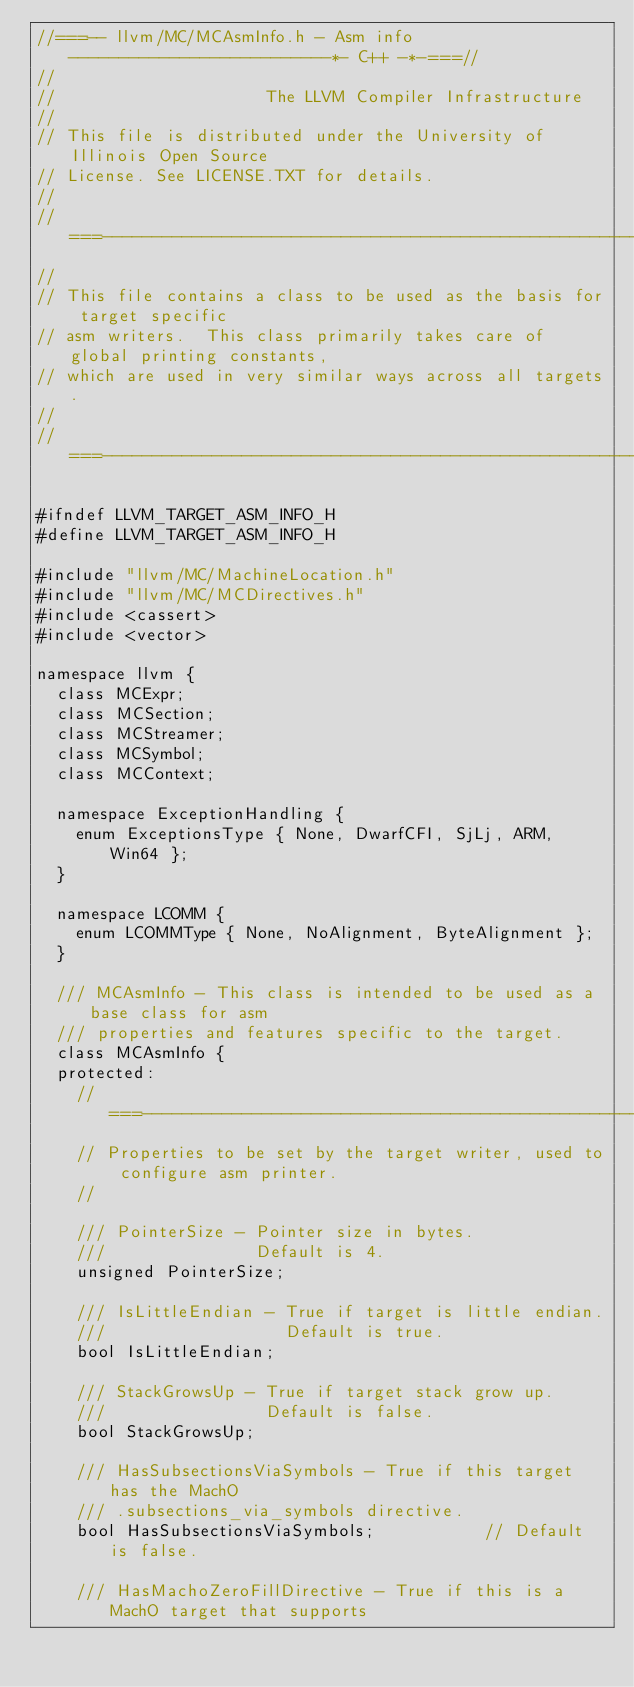Convert code to text. <code><loc_0><loc_0><loc_500><loc_500><_C_>//===-- llvm/MC/MCAsmInfo.h - Asm info --------------------------*- C++ -*-===//
//
//                     The LLVM Compiler Infrastructure
//
// This file is distributed under the University of Illinois Open Source
// License. See LICENSE.TXT for details.
//
//===----------------------------------------------------------------------===//
//
// This file contains a class to be used as the basis for target specific
// asm writers.  This class primarily takes care of global printing constants,
// which are used in very similar ways across all targets.
//
//===----------------------------------------------------------------------===//

#ifndef LLVM_TARGET_ASM_INFO_H
#define LLVM_TARGET_ASM_INFO_H

#include "llvm/MC/MachineLocation.h"
#include "llvm/MC/MCDirectives.h"
#include <cassert>
#include <vector>

namespace llvm {
  class MCExpr;
  class MCSection;
  class MCStreamer;
  class MCSymbol;
  class MCContext;

  namespace ExceptionHandling {
    enum ExceptionsType { None, DwarfCFI, SjLj, ARM, Win64 };
  }

  namespace LCOMM {
    enum LCOMMType { None, NoAlignment, ByteAlignment };
  }

  /// MCAsmInfo - This class is intended to be used as a base class for asm
  /// properties and features specific to the target.
  class MCAsmInfo {
  protected:
    //===------------------------------------------------------------------===//
    // Properties to be set by the target writer, used to configure asm printer.
    //

    /// PointerSize - Pointer size in bytes.
    ///               Default is 4.
    unsigned PointerSize;

    /// IsLittleEndian - True if target is little endian.
    ///                  Default is true.
    bool IsLittleEndian;

    /// StackGrowsUp - True if target stack grow up.
    ///                Default is false.
    bool StackGrowsUp;

    /// HasSubsectionsViaSymbols - True if this target has the MachO
    /// .subsections_via_symbols directive.
    bool HasSubsectionsViaSymbols;           // Default is false.

    /// HasMachoZeroFillDirective - True if this is a MachO target that supports</code> 